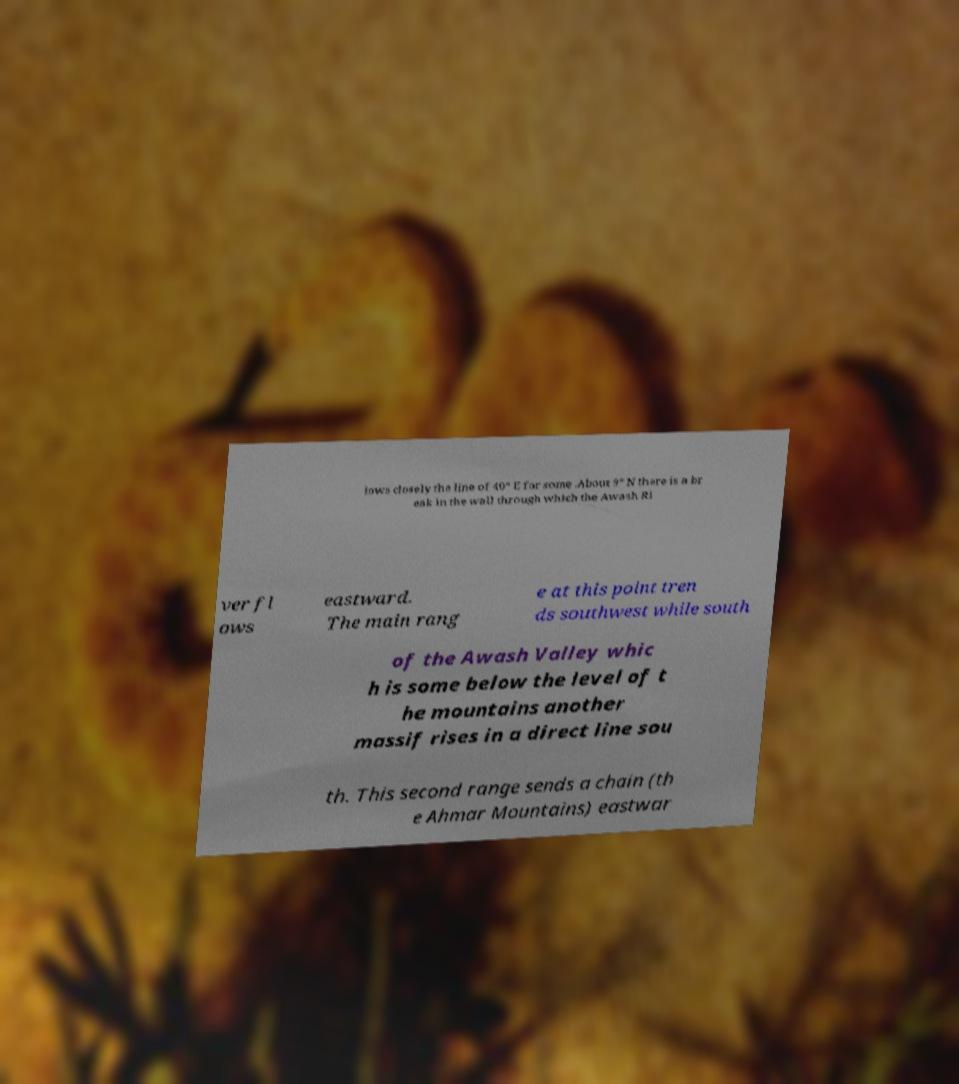There's text embedded in this image that I need extracted. Can you transcribe it verbatim? lows closely the line of 40° E for some .About 9° N there is a br eak in the wall through which the Awash Ri ver fl ows eastward. The main rang e at this point tren ds southwest while south of the Awash Valley whic h is some below the level of t he mountains another massif rises in a direct line sou th. This second range sends a chain (th e Ahmar Mountains) eastwar 